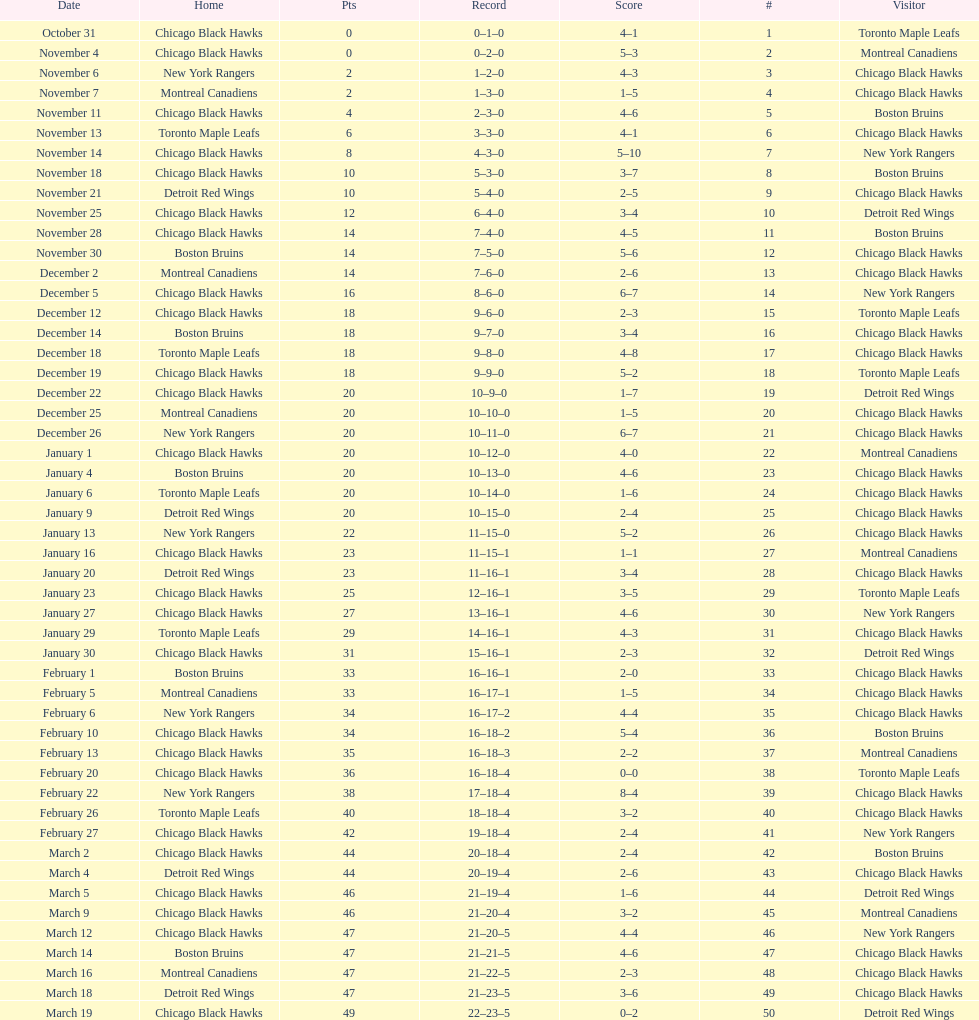What is was the difference in score in the december 19th win? 3. 